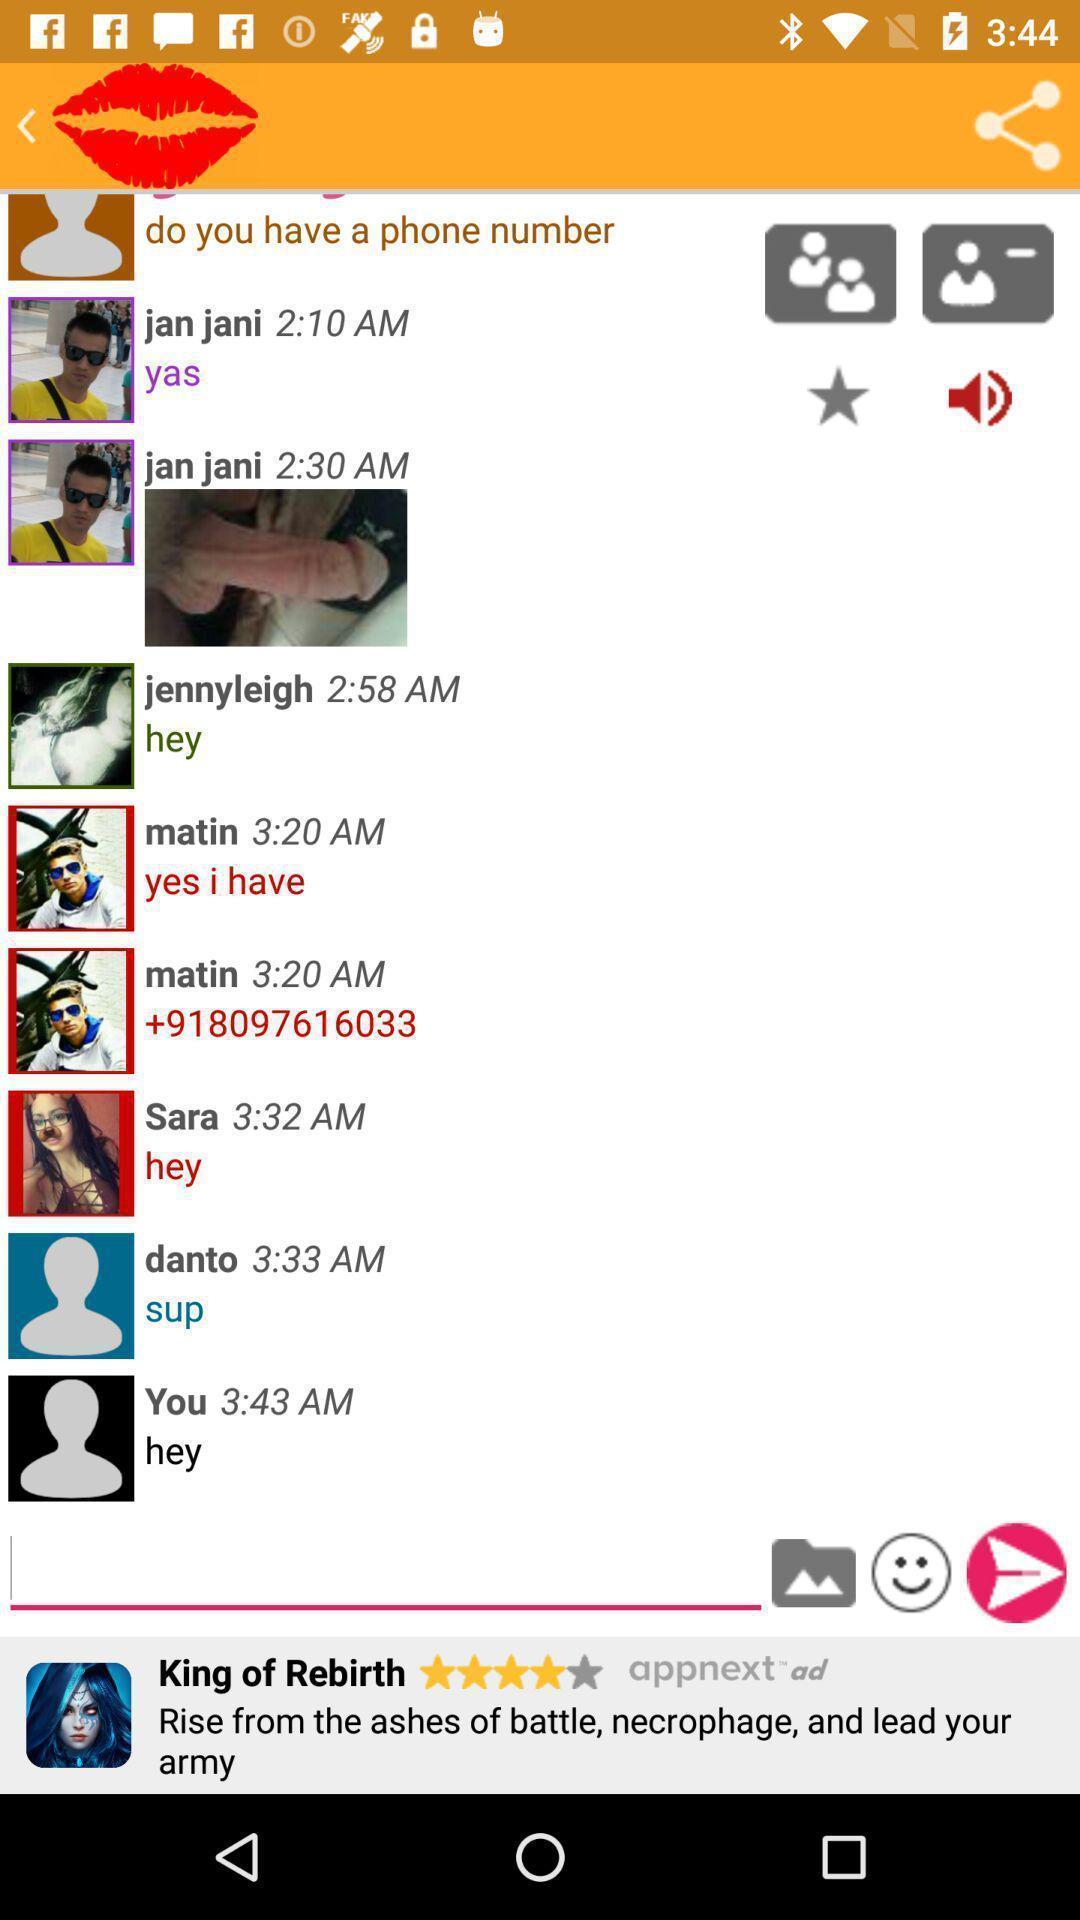Summarize the information in this screenshot. Screen shows a chat with multiple options. 